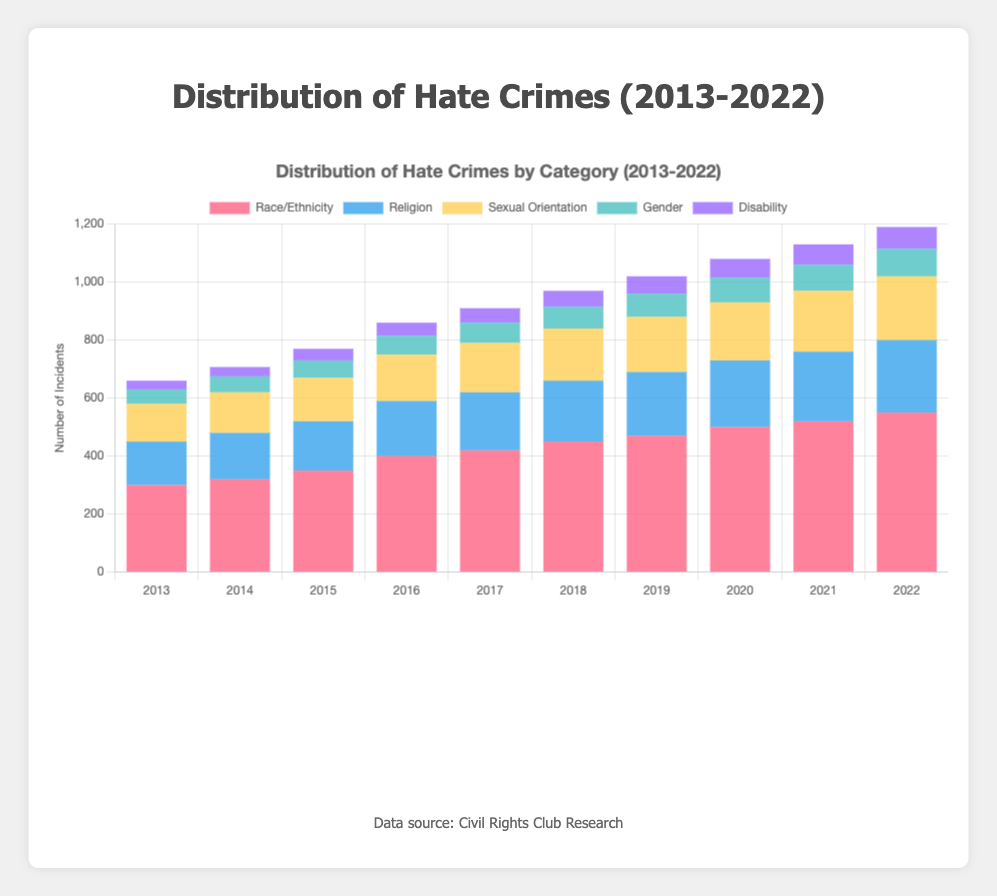What's the trend of hate crimes related to Race/Ethnicity over the years? By looking at each year's bar section for Race/Ethnicity from 2013 to 2022, we observe that the count increases steadily every year, indicating a rising trend.
Answer: Increasing Which year had the highest number of hate crimes related to Religion? By comparing the height of the Religion sections of the bars across all years, it's clear that 2022 had the highest number of incidents.
Answer: 2022 What is the total number of hate crimes in 2021? Adding the bars' heights of each category in 2021: 520 (Race/Ethnicity) + 240 (Religion) + 210 (Sexual Orientation) + 90 (Gender) + 70 (Disability) = 1130.
Answer: 1130 How do the hate crimes related to Gender in 2016 and 2022 compare? In 2016, the height for Gender is 65 and in 2022 it is 95. Comparing these values shows that the number in 2022 is higher than in 2016.
Answer: 2022 > 2016 Which category has the smallest number of hate crimes throughout the years? By examining the bars, Disability consistently has the smallest numbers in each year.
Answer: Disability In what year did the total number of hate crimes first exceed 1000? Summing the height of all category bars year by year shows that in 2019 the total exceeds 1000 for the first time: 470 + 220 + 190 + 80 + 60 = 1020.
Answer: 2019 How does the distribution of hate crimes related to Sexual Orientation in 2019 compare visually to those in 2013? The height of the Sexual Orientation bar in 2019 is significantly higher than in 2013, indicating an increase.
Answer: Higher in 2019 What's the average number of hate crimes related to Disability from 2013 to 2022? Summing the Disability numbers: 30 + 32 + 40 + 45 + 50 + 55 + 60 + 65 + 70 + 75 = 522, then dividing by 10 years: 522/10 = 52.2
Answer: 52.2 What is the proportion of hate crimes related to Religion in 2020 compared to the total hate crimes that year? Religion in 2020 is 230. The total for 2020 is 500 + 230 + 200 + 85 + 65 = 1080. So, the proportion is 230/1080 = 0.213 or 21.3%.
Answer: 21.3% Has the proportion of hate crimes related to Sexual Orientation increased or decreased from 2013 to 2022? In 2013 the count for Sexual Orientation is 130 and the total is 660. In 2022, it's 220 out of 1190. The proportions are 130/660 = 19.7% in 2013 and 220/1190 = 18.5% in 2022. Thus, it slightly decreased.
Answer: Decreased 